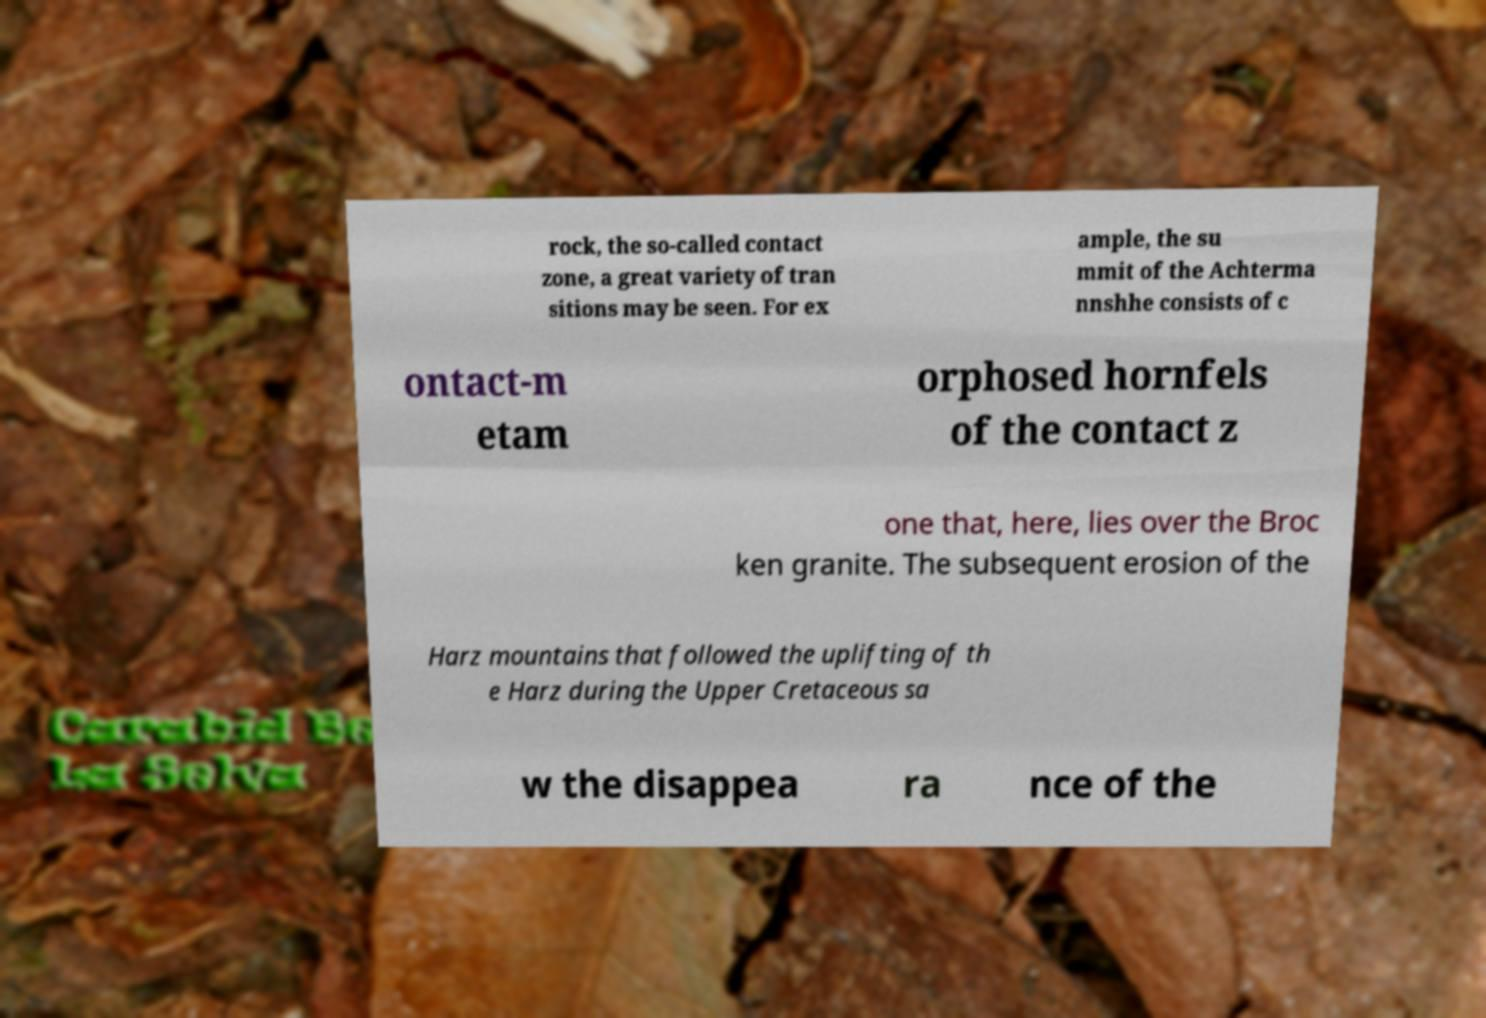Could you extract and type out the text from this image? rock, the so-called contact zone, a great variety of tran sitions may be seen. For ex ample, the su mmit of the Achterma nnshhe consists of c ontact-m etam orphosed hornfels of the contact z one that, here, lies over the Broc ken granite. The subsequent erosion of the Harz mountains that followed the uplifting of th e Harz during the Upper Cretaceous sa w the disappea ra nce of the 